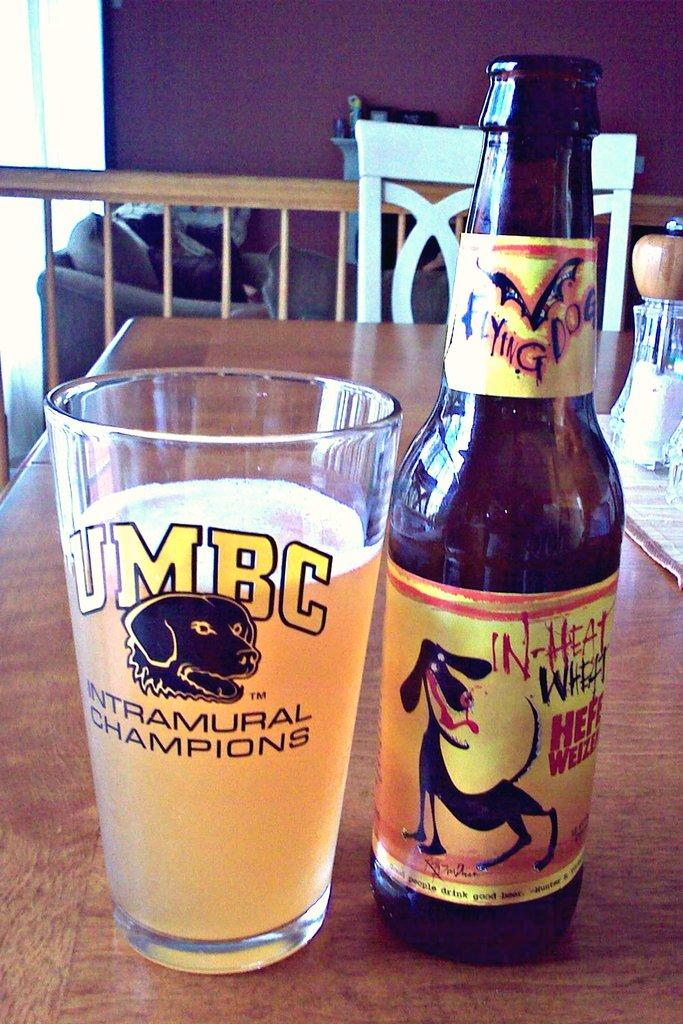What piece of furniture is present in the image? There is a table in the image. What is placed on the table? There is a glass and a bottle on the table. What type of seating is visible in the image? There is a chair in the image. What architectural feature can be seen in the image? There is a wall in the image. How many pairs of shoes are visible in the image? There are no shoes present in the image. What type of celebration is taking place in the image? There is no indication of a celebration or birthday in the image. 